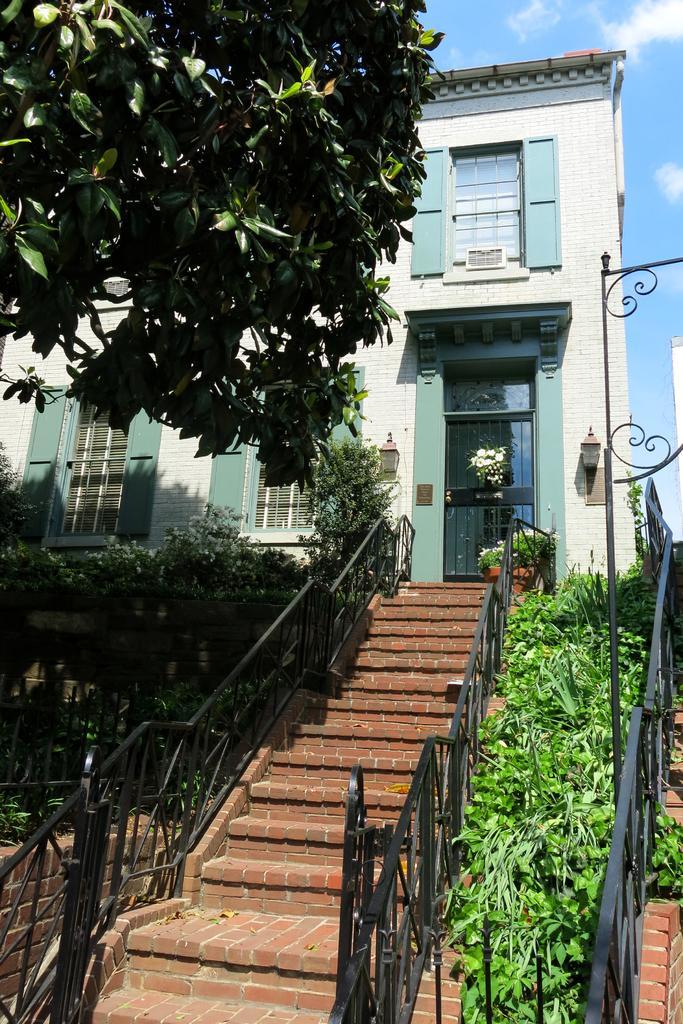Please provide a concise description of this image. In this image we can see a building with windows, door, a lamp and a staircase. We can also see some plants, a tree, a fence and the sky which looks cloudy. 